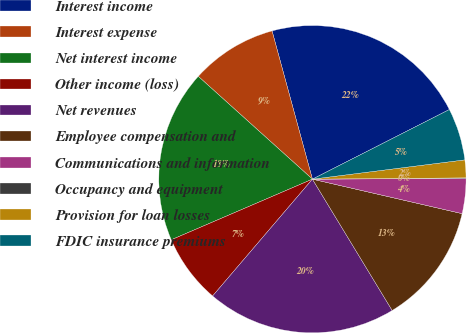Convert chart to OTSL. <chart><loc_0><loc_0><loc_500><loc_500><pie_chart><fcel>Interest income<fcel>Interest expense<fcel>Net interest income<fcel>Other income (loss)<fcel>Net revenues<fcel>Employee compensation and<fcel>Communications and information<fcel>Occupancy and equipment<fcel>Provision for loan losses<fcel>FDIC insurance premiums<nl><fcel>21.75%<fcel>9.1%<fcel>18.13%<fcel>7.29%<fcel>19.94%<fcel>12.71%<fcel>3.68%<fcel>0.06%<fcel>1.87%<fcel>5.48%<nl></chart> 